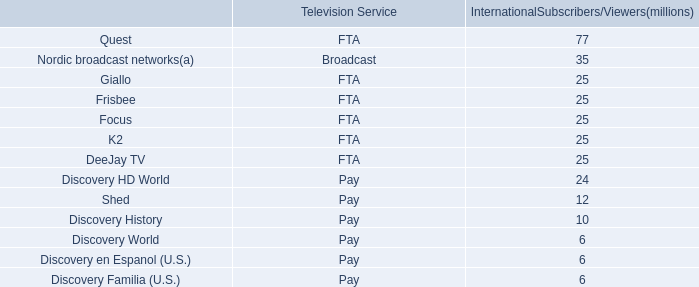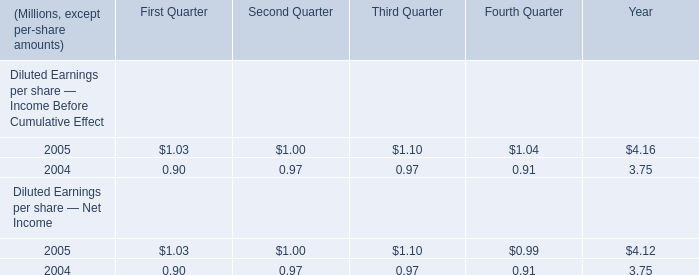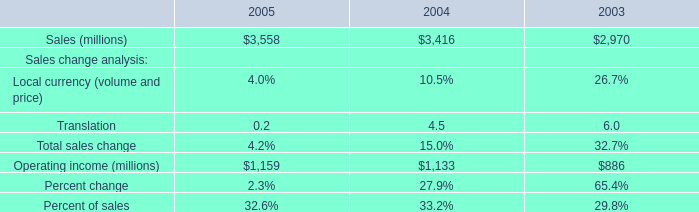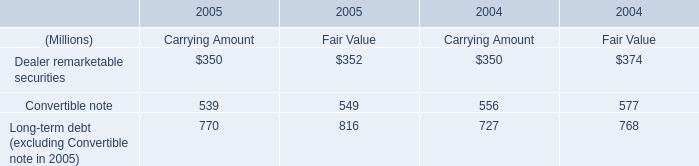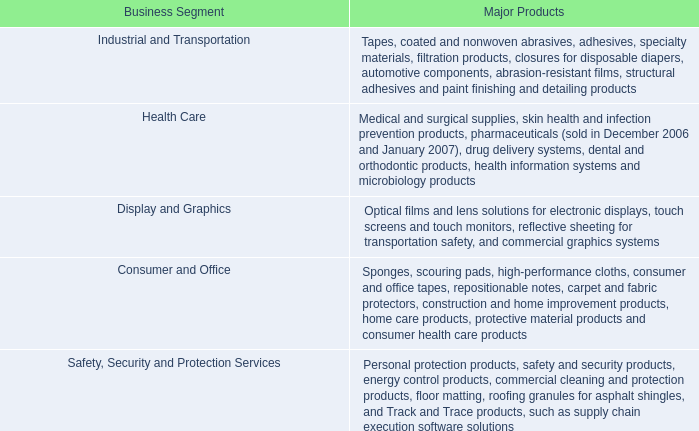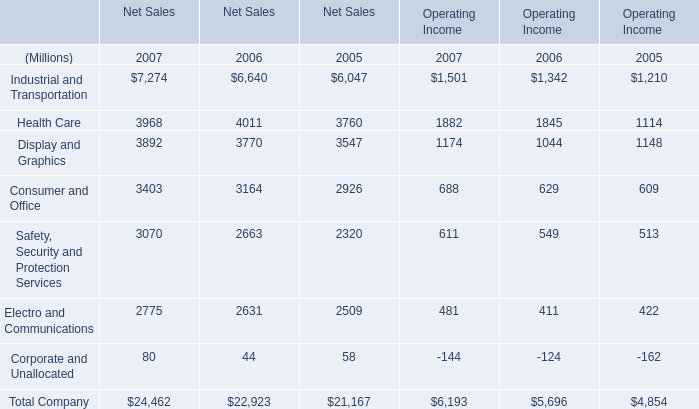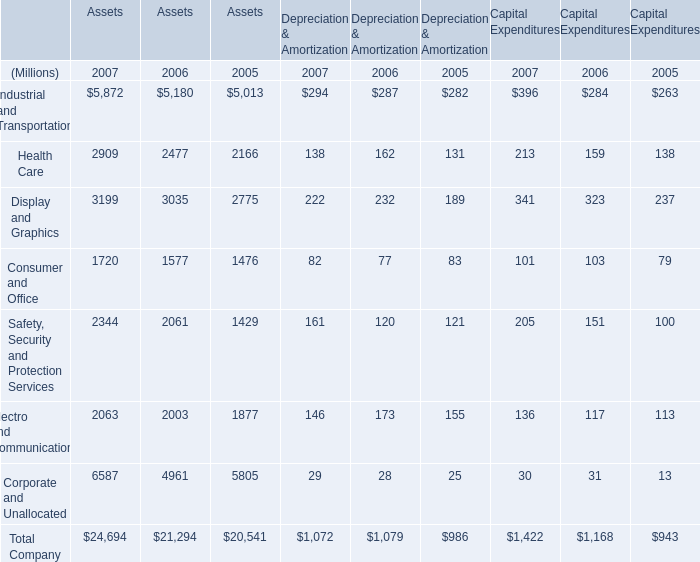What was the total amount of Industrial and Transportation, Health Care, Display and Graphics and Consumer and Office for Assets in 2007 ? (in Million) 
Computations: (((5872 + 2909) + 3199) + 1720)
Answer: 13700.0. 